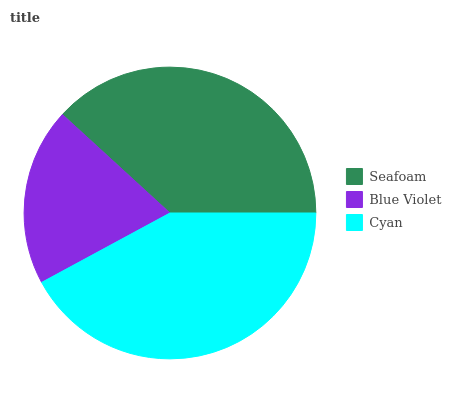Is Blue Violet the minimum?
Answer yes or no. Yes. Is Cyan the maximum?
Answer yes or no. Yes. Is Cyan the minimum?
Answer yes or no. No. Is Blue Violet the maximum?
Answer yes or no. No. Is Cyan greater than Blue Violet?
Answer yes or no. Yes. Is Blue Violet less than Cyan?
Answer yes or no. Yes. Is Blue Violet greater than Cyan?
Answer yes or no. No. Is Cyan less than Blue Violet?
Answer yes or no. No. Is Seafoam the high median?
Answer yes or no. Yes. Is Seafoam the low median?
Answer yes or no. Yes. Is Blue Violet the high median?
Answer yes or no. No. Is Cyan the low median?
Answer yes or no. No. 